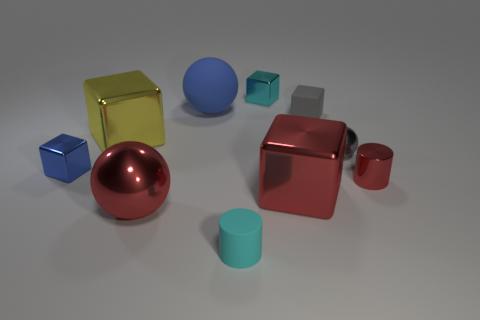Subtract all yellow cubes. How many cubes are left? 4 Subtract all metal balls. How many balls are left? 1 Subtract all cylinders. How many objects are left? 8 Subtract 1 cubes. How many cubes are left? 4 Subtract all purple spheres. Subtract all red cylinders. How many spheres are left? 3 Subtract all red cubes. How many blue balls are left? 1 Subtract all small metallic balls. Subtract all tiny red shiny spheres. How many objects are left? 9 Add 1 rubber spheres. How many rubber spheres are left? 2 Add 3 gray objects. How many gray objects exist? 5 Subtract 0 blue cylinders. How many objects are left? 10 